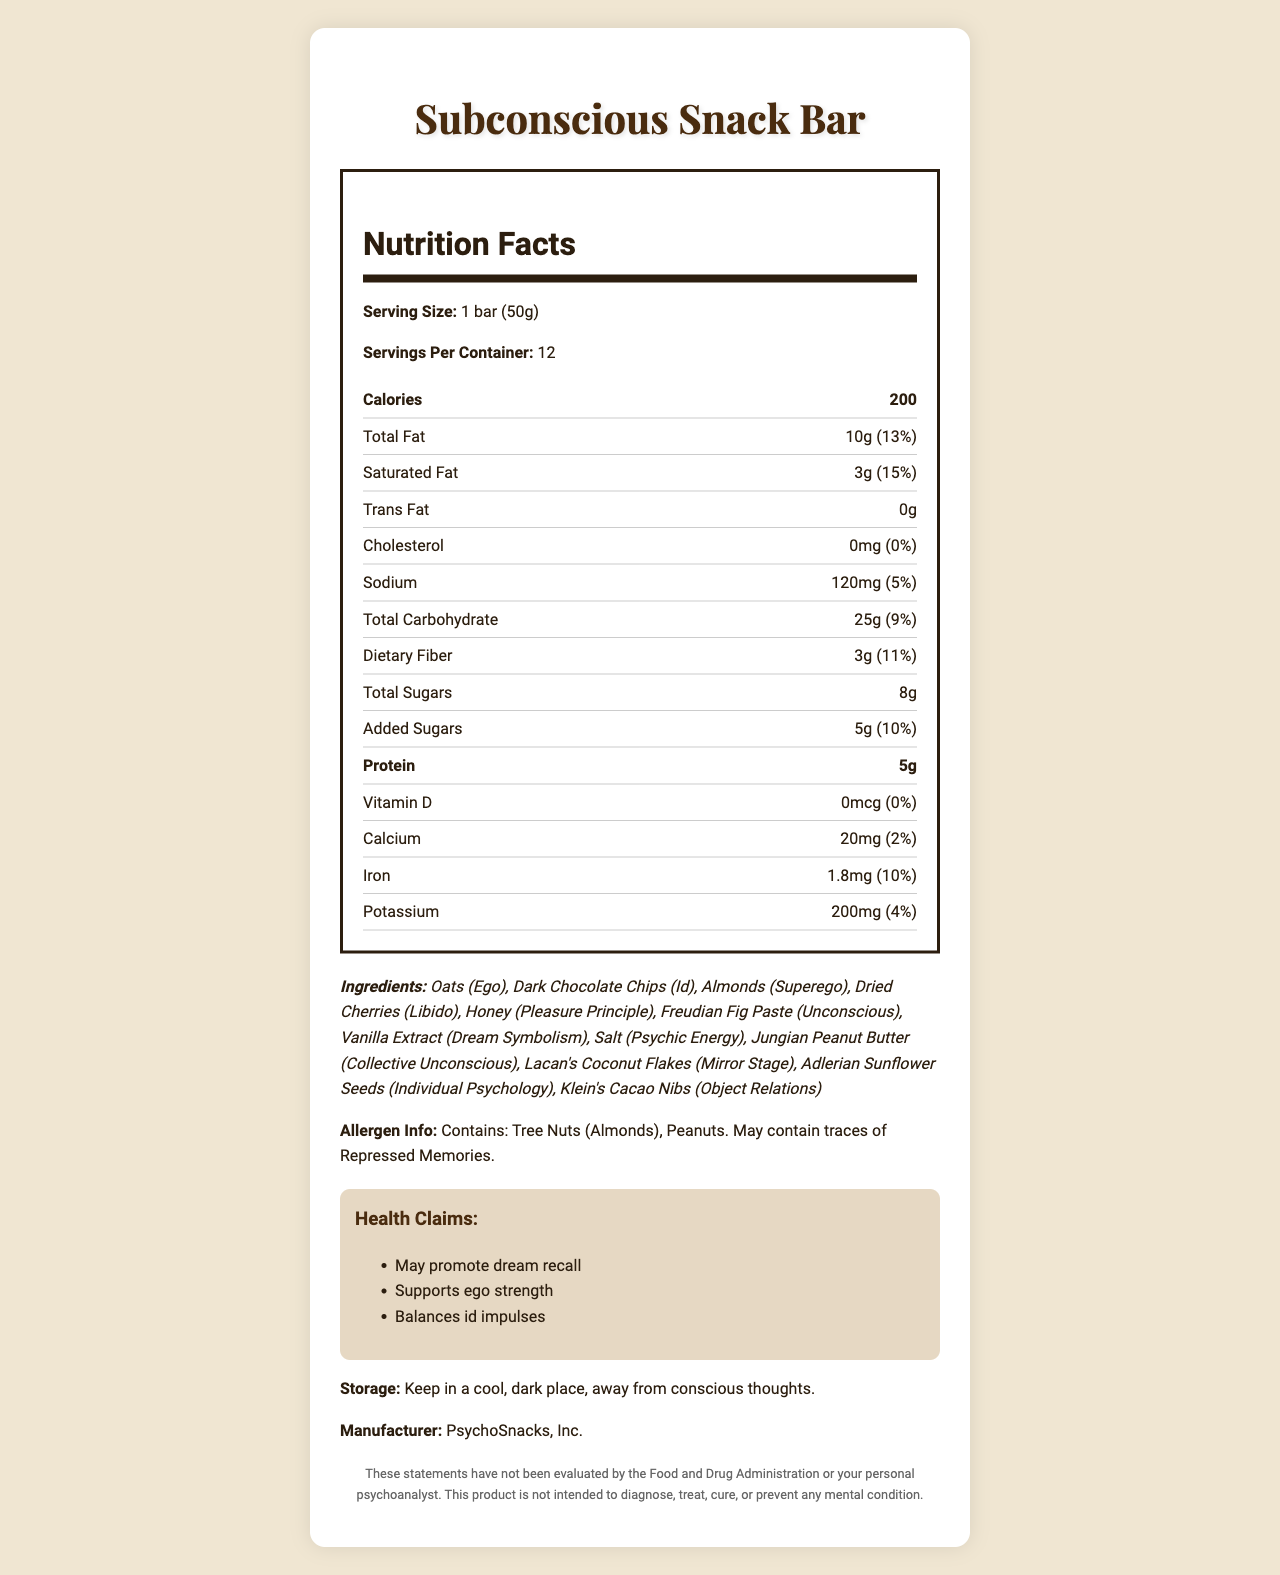what is the serving size for the Subconscious Snack Bar? The serving size is clearly mentioned as "1 bar (50g)" in the Nutrition Facts section of the document.
Answer: 1 bar (50g) how many servings are there per container? The document states "Servings Per Container: 12" in the Nutrition Facts section.
Answer: 12 how many calories are in one serving of the Subconscious Snack Bar? The document lists the calories per serving as 200.
Answer: 200 what allergens are present in the Subconscious Snack Bar? The allergen information listed in the document states "Contains: Tree Nuts (Almonds), Peanuts."
Answer: Tree Nuts (Almonds), Peanuts what percentage of the daily value is the total fat in one bar? The daily value percentage for total fat is provided as 13% in the Nutrition Facts section.
Answer: 13% what are some of the health claims mentioned for the Subconscious Snack Bar? The listed health claims include "May promote dream recall," "Supports ego strength," and "Balances id impulses."
Answer: May promote dream recall, Supports ego strength, Balances id impulses which ingredient is associated with the Unconscious according to Freudian symbolism? The ingredients list "Freudian Fig Paste" as the element corresponding to the Unconscious.
Answer: Freudian Fig Paste how much protein is in one Subconscious Snack Bar? According to the Nutrition Facts, there is 5g of protein per serving.
Answer: 5g what's the daily value percentage for added sugars? The daily value for added sugars is listed as 10% in the Nutrition Facts section.
Answer: 10% where should the Subconscious Snack Bar be stored? The storage instructions state to "Keep in a cool, dark place, away from conscious thoughts."
Answer: Keep in a cool, dark place, away from conscious thoughts which element symbolizes the "Ego" in the ingredient list? A. Dark Chocolate Chips B. Almonds C. Oats D. Honey The document indicates that "Oats" correspond to the "Ego."
Answer: C. Oats what is the amount of potassium in one bar? A. 100mg B. 150mg C. 200mg D. 250mg The Nutrition Facts list the potassium content as 200mg.
Answer: C. 200mg is there any trans fat in the Subconscious Snack Bar? The document states the amount of trans fat is 0g.
Answer: No summarize the main idea of the Subconscious Snack Bar's label. The label includes detailed nutrition facts, a unique ingredients list with psychological symbolism, allergen warnings, health claims, storage instructions, and a disclaimer from the manufacturer.
Answer: The Subconscious Snack Bar offers a combination of ingredients inspired by Freudian symbolism, designed to nourish both the body and the mind. The nutrition label details the calorie and nutrient content per serving, emphasizes the allergen information, and highlights health claims tied to psychological benefits. what is the sodium amount in one Subconscious Snack Bar? According to the Nutrition Facts, the sodium content per serving is 120mg.
Answer: 120mg who is the manufacturer of the Subconscious Snack Bar? The manufacturer is clearly mentioned as PsychoSnacks, Inc.
Answer: PsychoSnacks, Inc. how much dietary fiber is in a single serving of the Subconscious Snack Bar? The document lists 3g of dietary fiber per serving in the Nutrition Facts section.
Answer: 3g have the statements on this label been evaluated by the Food and Drug Administration? The disclaimer at the end of the document states that these statements have not been evaluated by the Food and Drug Administration.
Answer: No what are the potential allergens mentioned in the ingredients? A. Oats and Vanilla Extract B. Tree Nuts and Peanuts C. Oats and Almonds D. Peanuts and Honey The allergen information specifies Tree Nuts (Almonds) and Peanuts.
Answer: B. Tree Nuts and Peanuts 